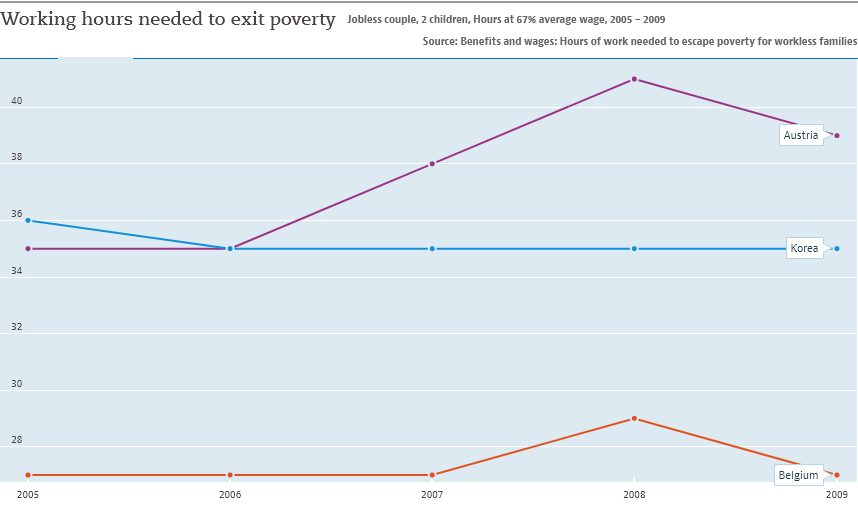Point out several critical features in this image. The color of the line that represents Korea in the given context is blue. The sum of the GDPs of South Korea and Belgium in 2009 was greater than the GDP of Austria in 2008. 